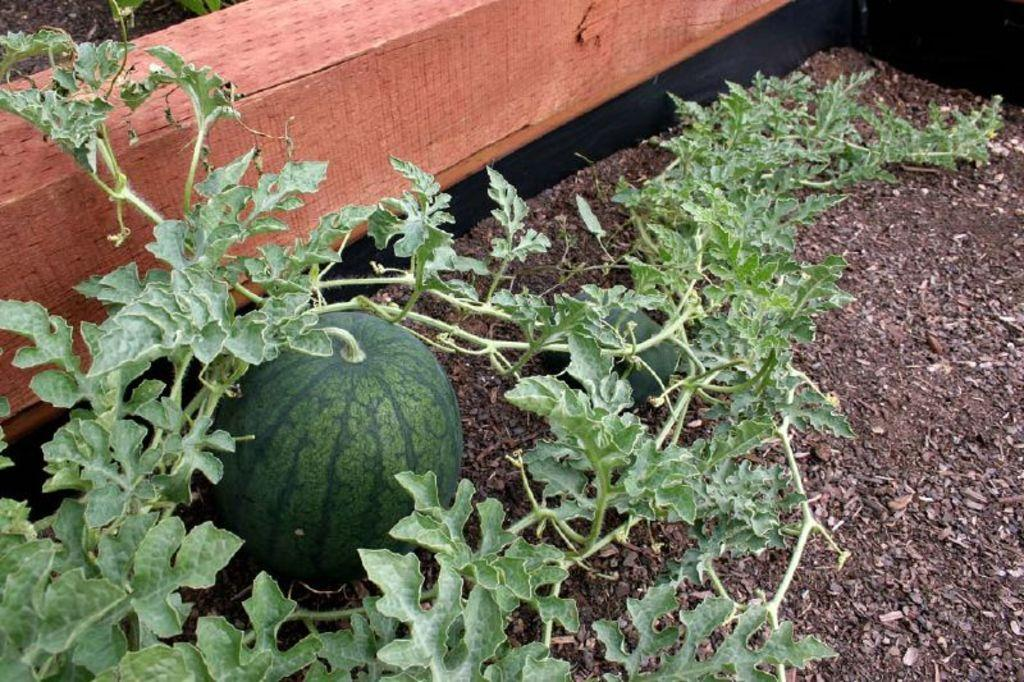What type of vegetation is visible in the front of the image? There are plants in the front of the image. What type of food can be seen in the image? There are fruits in the image. Can you describe the object in the background of the image? Unfortunately, the facts provided do not give enough information to describe the object in the background. What flavor of cloth is draped over the basket in the image? There is no cloth or basket present in the image. 